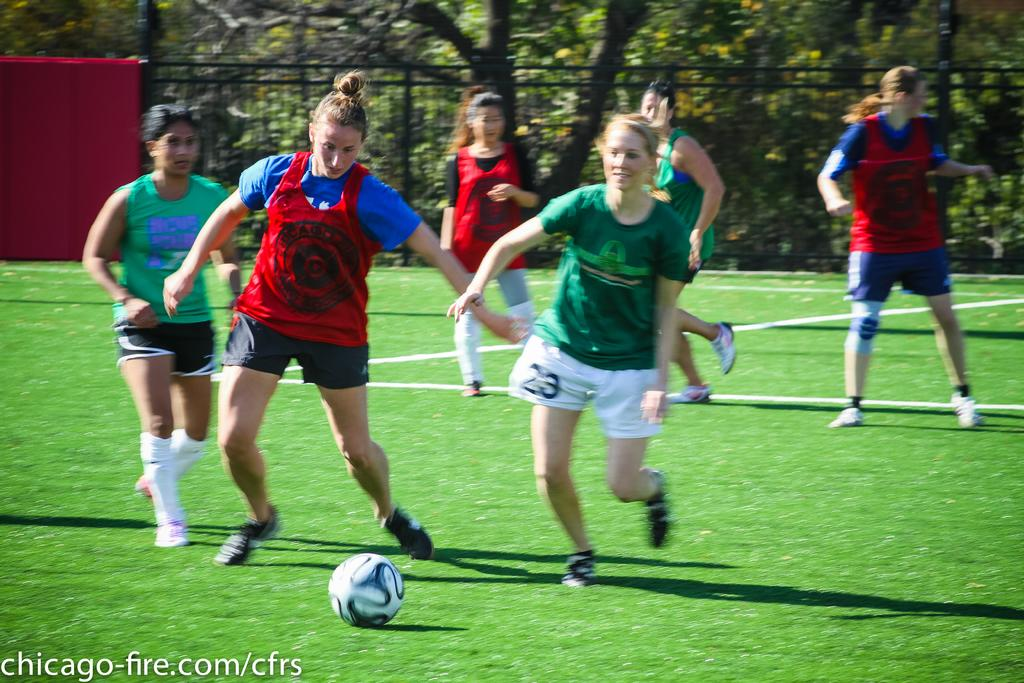<image>
Provide a brief description of the given image. In the lower left of an image of girls playing soccer is a chicago-fire.com logo. 